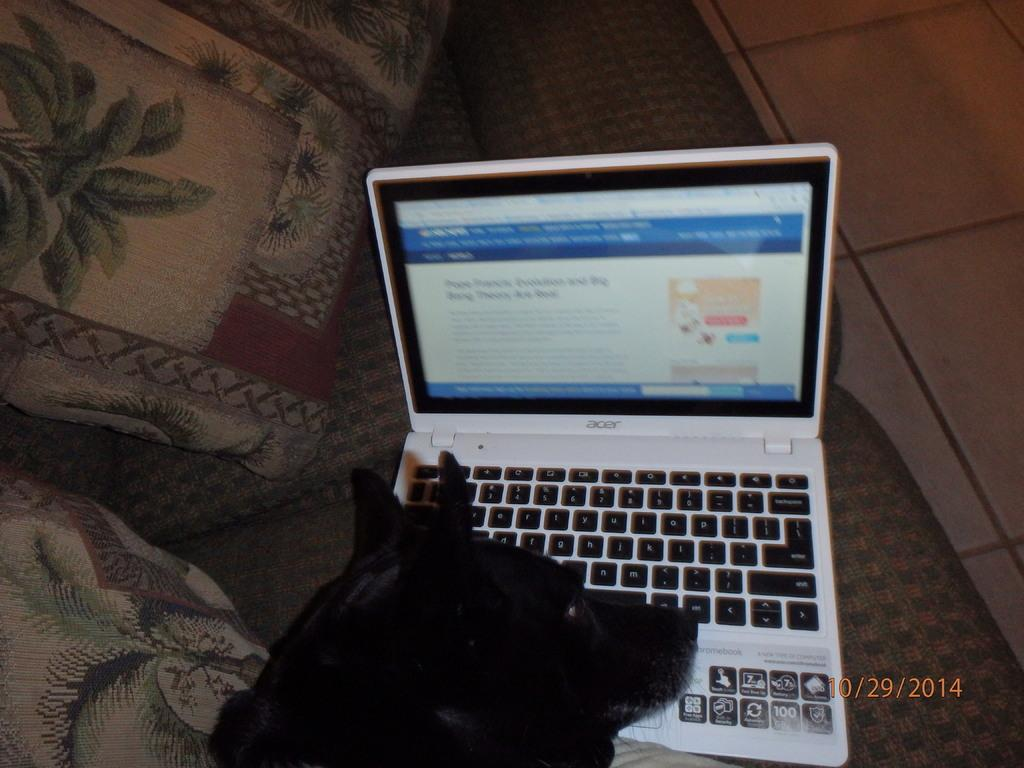<image>
Create a compact narrative representing the image presented. a black dog in front of a lap top computer taken on 10/29/2014 